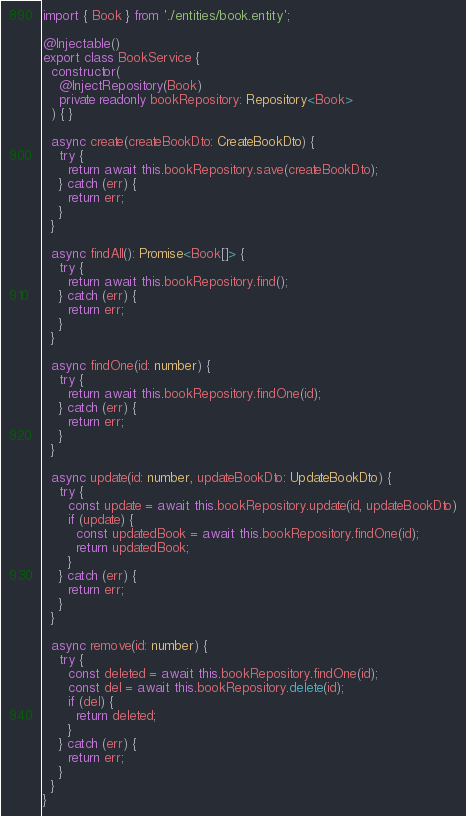<code> <loc_0><loc_0><loc_500><loc_500><_TypeScript_>import { Book } from './entities/book.entity';

@Injectable()
export class BookService {
  constructor(
    @InjectRepository(Book)
    private readonly bookRepository: Repository<Book>
  ) { }

  async create(createBookDto: CreateBookDto) {
    try {
      return await this.bookRepository.save(createBookDto);
    } catch (err) {
      return err;
    }
  }

  async findAll(): Promise<Book[]> {
    try {
      return await this.bookRepository.find();
    } catch (err) {
      return err;
    }
  }

  async findOne(id: number) {
    try {
      return await this.bookRepository.findOne(id);
    } catch (err) {
      return err;
    }
  }

  async update(id: number, updateBookDto: UpdateBookDto) {
    try {
      const update = await this.bookRepository.update(id, updateBookDto)
      if (update) {
        const updatedBook = await this.bookRepository.findOne(id);
        return updatedBook;
      }
    } catch (err) {
      return err;
    }
  }

  async remove(id: number) {
    try {
      const deleted = await this.bookRepository.findOne(id);
      const del = await this.bookRepository.delete(id);
      if (del) {
        return deleted;
      }
    } catch (err) {
      return err;
    }
  }
}
</code> 